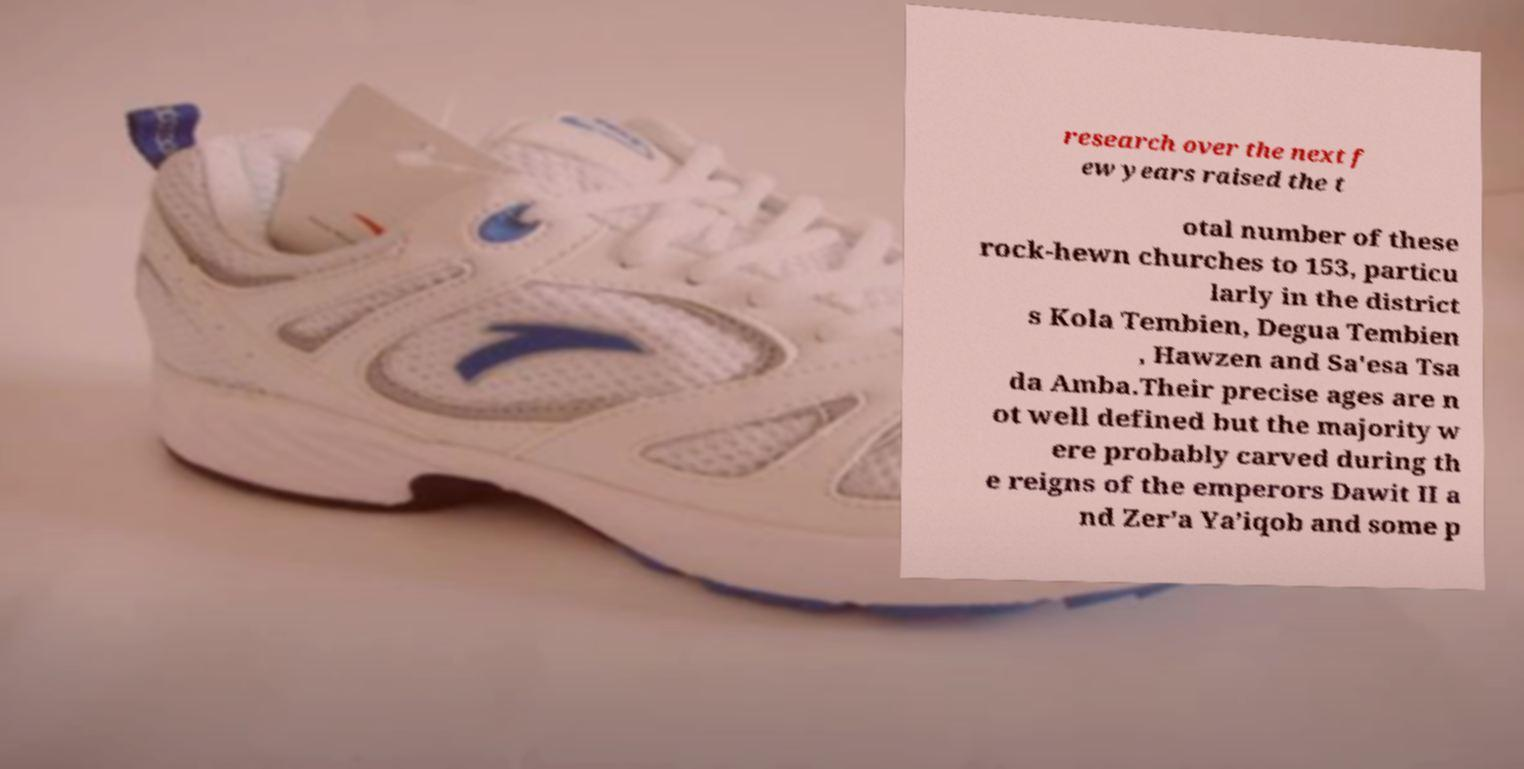Could you extract and type out the text from this image? research over the next f ew years raised the t otal number of these rock-hewn churches to 153, particu larly in the district s Kola Tembien, Degua Tembien , Hawzen and Sa'esa Tsa da Amba.Their precise ages are n ot well defined but the majority w ere probably carved during th e reigns of the emperors Dawit II a nd Zer’a Ya’iqob and some p 